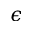Convert formula to latex. <formula><loc_0><loc_0><loc_500><loc_500>\epsilon</formula> 